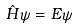<formula> <loc_0><loc_0><loc_500><loc_500>\hat { H } \psi = E \psi</formula> 